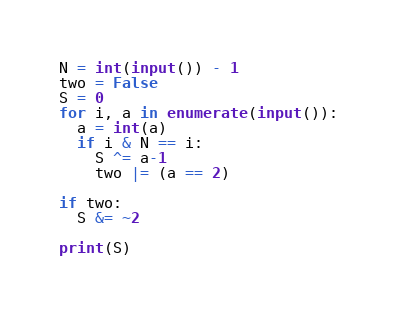<code> <loc_0><loc_0><loc_500><loc_500><_Python_>N = int(input()) - 1
two = False
S = 0
for i, a in enumerate(input()):
  a = int(a)
  if i & N == i:
    S ^= a-1
    two |= (a == 2)

if two:
  S &= ~2

print(S)
</code> 